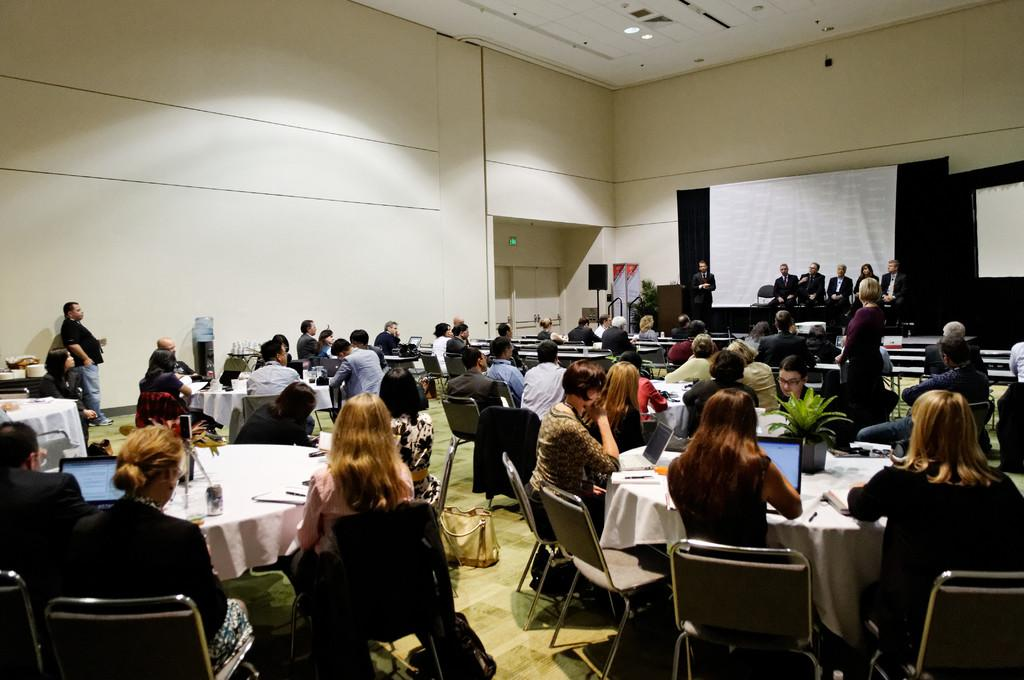What are the people in the image doing? There is a group of people sitting in chairs in the image. What is in front of the group of people? There is a table in front of the group of people. What can be found on the table? There are objects on the table. Where is the second group of people located in the image? There is another group of people sitting in the right corner of the image. What page of the book is the person reading in the image? There is no book or person reading in the image. What time of day is depicted in the image? The time of day is not specified in the image. 